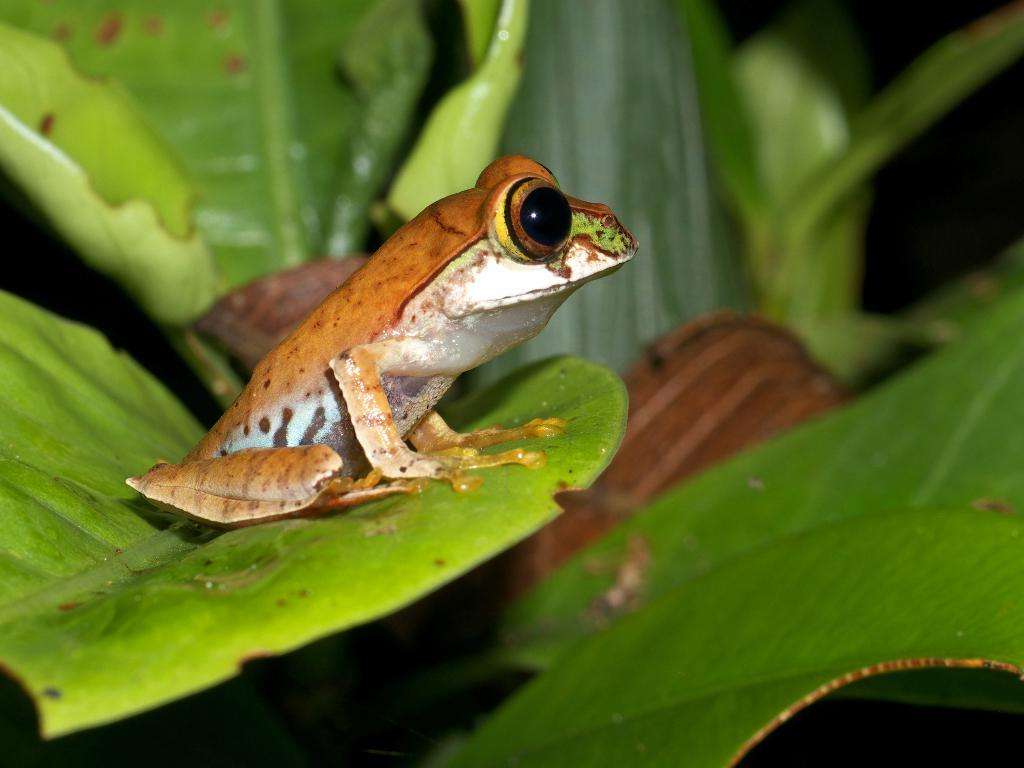What is the main subject of the image? There is a frog on a leaf in the image. How would you describe the background of the image? The background of the image is blurry. What else can be seen in the background of the image? Leaves are visible in the background of the image. What type of pan is being used to cook the seeds in the image? There is no pan or seeds present in the image; it features a frog on a leaf with a blurry background. 